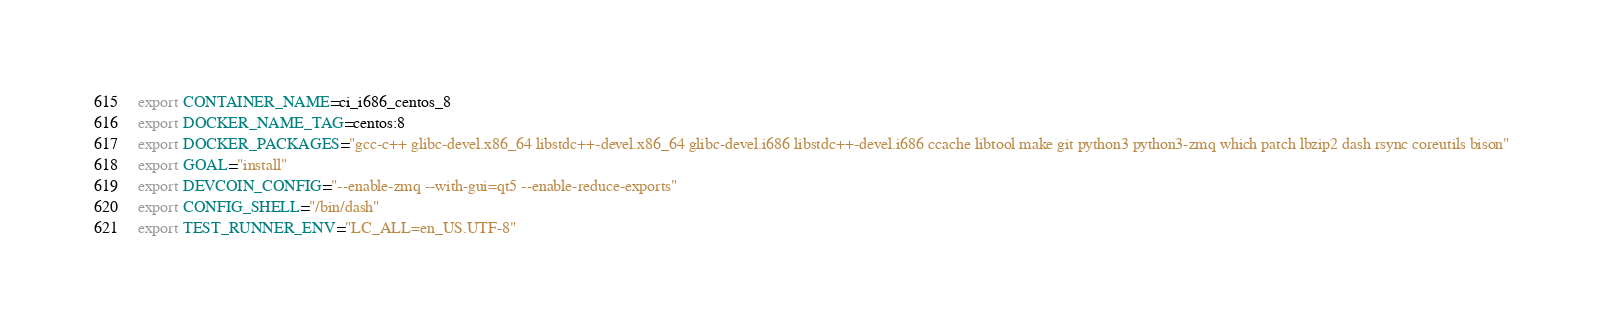Convert code to text. <code><loc_0><loc_0><loc_500><loc_500><_Bash_>export CONTAINER_NAME=ci_i686_centos_8
export DOCKER_NAME_TAG=centos:8
export DOCKER_PACKAGES="gcc-c++ glibc-devel.x86_64 libstdc++-devel.x86_64 glibc-devel.i686 libstdc++-devel.i686 ccache libtool make git python3 python3-zmq which patch lbzip2 dash rsync coreutils bison"
export GOAL="install"
export DEVCOIN_CONFIG="--enable-zmq --with-gui=qt5 --enable-reduce-exports"
export CONFIG_SHELL="/bin/dash"
export TEST_RUNNER_ENV="LC_ALL=en_US.UTF-8"
</code> 